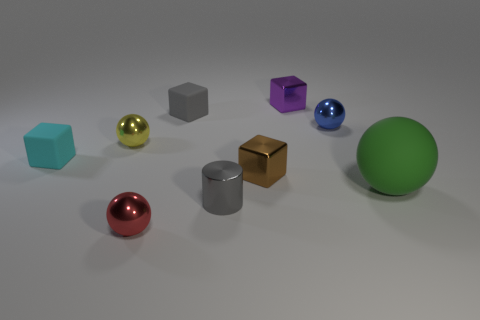There is a tiny cylinder; is it the same color as the tiny matte object that is right of the red metallic object?
Provide a short and direct response. Yes. How many objects are spheres left of the purple thing or green rubber objects?
Provide a short and direct response. 3. How many large things are in front of the metallic ball that is to the right of the ball in front of the gray metal thing?
Offer a terse response. 1. Are there any other things that are the same size as the green rubber ball?
Your answer should be compact. No. There is a tiny matte object to the left of the metal ball on the left side of the tiny metal sphere that is in front of the tiny cyan thing; what is its shape?
Keep it short and to the point. Cube. How many other things are the same color as the tiny cylinder?
Your response must be concise. 1. There is a small matte thing in front of the blue ball on the left side of the big matte ball; what is its shape?
Your answer should be very brief. Cube. There is a tiny cyan block; what number of small cubes are behind it?
Make the answer very short. 2. Is there a block that has the same material as the cylinder?
Provide a succinct answer. Yes. There is a purple thing that is the same size as the brown shiny object; what is its material?
Offer a very short reply. Metal. 